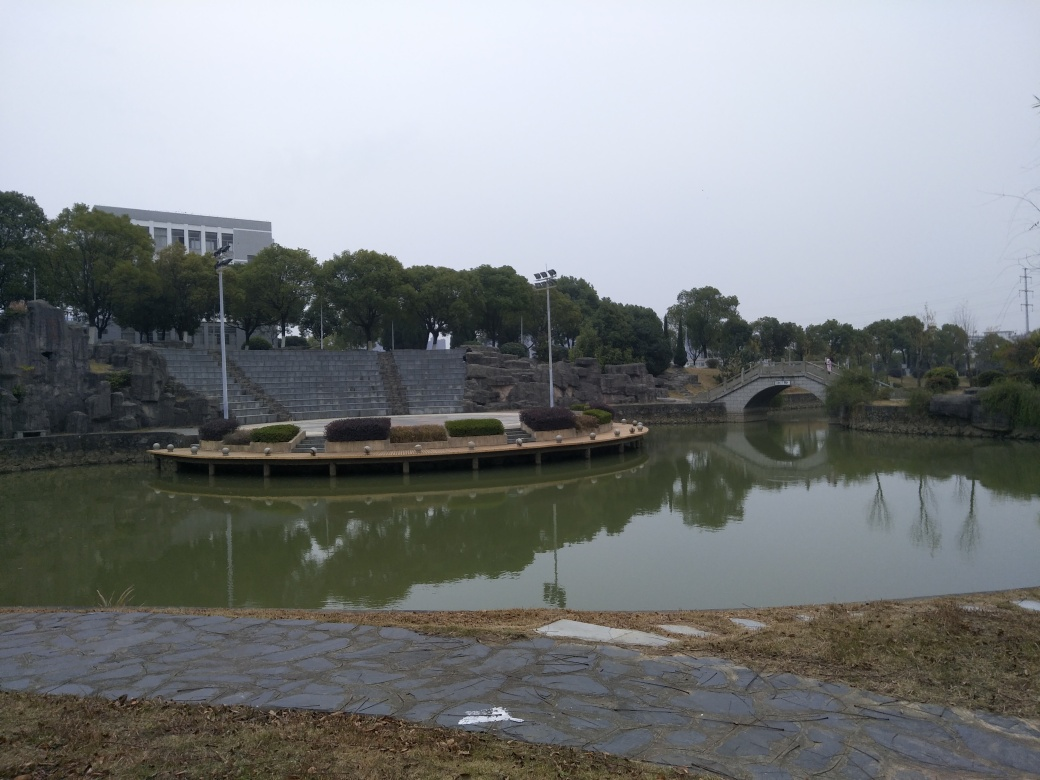Could you suggest how this landscape might be improved? Improving this landscape could involve enhancing the greenery, such as by adding flowers or shrubs with vibrant colors to introduce contrast and visual interest. Additionally, maintaining the lawn and perhaps redesigning the pavement with a more naturalistic pathway could enhance the green space. Introducing elements like a small fountain or statues could also add focal points and improve the overall aesthetic. 